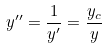<formula> <loc_0><loc_0><loc_500><loc_500>y ^ { \prime \prime } = \frac { 1 } { y ^ { \prime } } = \frac { y _ { c } } { y }</formula> 